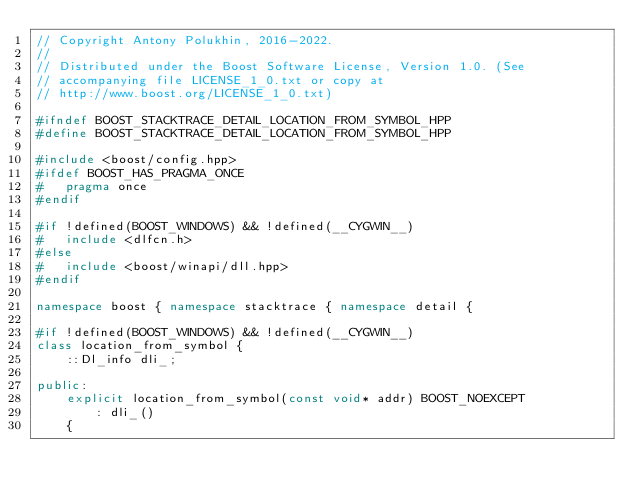Convert code to text. <code><loc_0><loc_0><loc_500><loc_500><_C++_>// Copyright Antony Polukhin, 2016-2022.
//
// Distributed under the Boost Software License, Version 1.0. (See
// accompanying file LICENSE_1_0.txt or copy at
// http://www.boost.org/LICENSE_1_0.txt)

#ifndef BOOST_STACKTRACE_DETAIL_LOCATION_FROM_SYMBOL_HPP
#define BOOST_STACKTRACE_DETAIL_LOCATION_FROM_SYMBOL_HPP

#include <boost/config.hpp>
#ifdef BOOST_HAS_PRAGMA_ONCE
#   pragma once
#endif

#if !defined(BOOST_WINDOWS) && !defined(__CYGWIN__)
#   include <dlfcn.h>
#else
#   include <boost/winapi/dll.hpp>
#endif

namespace boost { namespace stacktrace { namespace detail {

#if !defined(BOOST_WINDOWS) && !defined(__CYGWIN__)
class location_from_symbol {
    ::Dl_info dli_;

public:
    explicit location_from_symbol(const void* addr) BOOST_NOEXCEPT
        : dli_()
    {</code> 